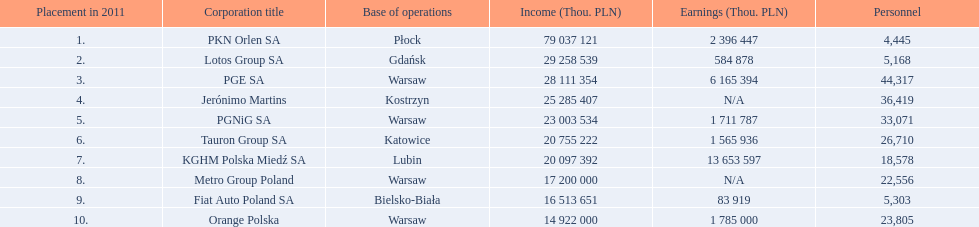What are the names of the major companies of poland? PKN Orlen SA, Lotos Group SA, PGE SA, Jerónimo Martins, PGNiG SA, Tauron Group SA, KGHM Polska Miedź SA, Metro Group Poland, Fiat Auto Poland SA, Orange Polska. What are the revenues of those companies in thou. pln? PKN Orlen SA, 79 037 121, Lotos Group SA, 29 258 539, PGE SA, 28 111 354, Jerónimo Martins, 25 285 407, PGNiG SA, 23 003 534, Tauron Group SA, 20 755 222, KGHM Polska Miedź SA, 20 097 392, Metro Group Poland, 17 200 000, Fiat Auto Poland SA, 16 513 651, Orange Polska, 14 922 000. Which of these revenues is greater than 75 000 000 thou. pln? 79 037 121. Which company has a revenue equal to 79 037 121 thou pln? PKN Orlen SA. 